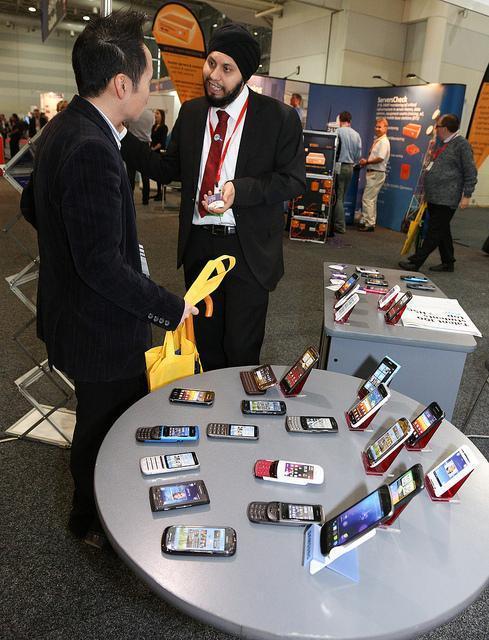How many people are visible?
Give a very brief answer. 3. How many cell phones are visible?
Give a very brief answer. 2. 